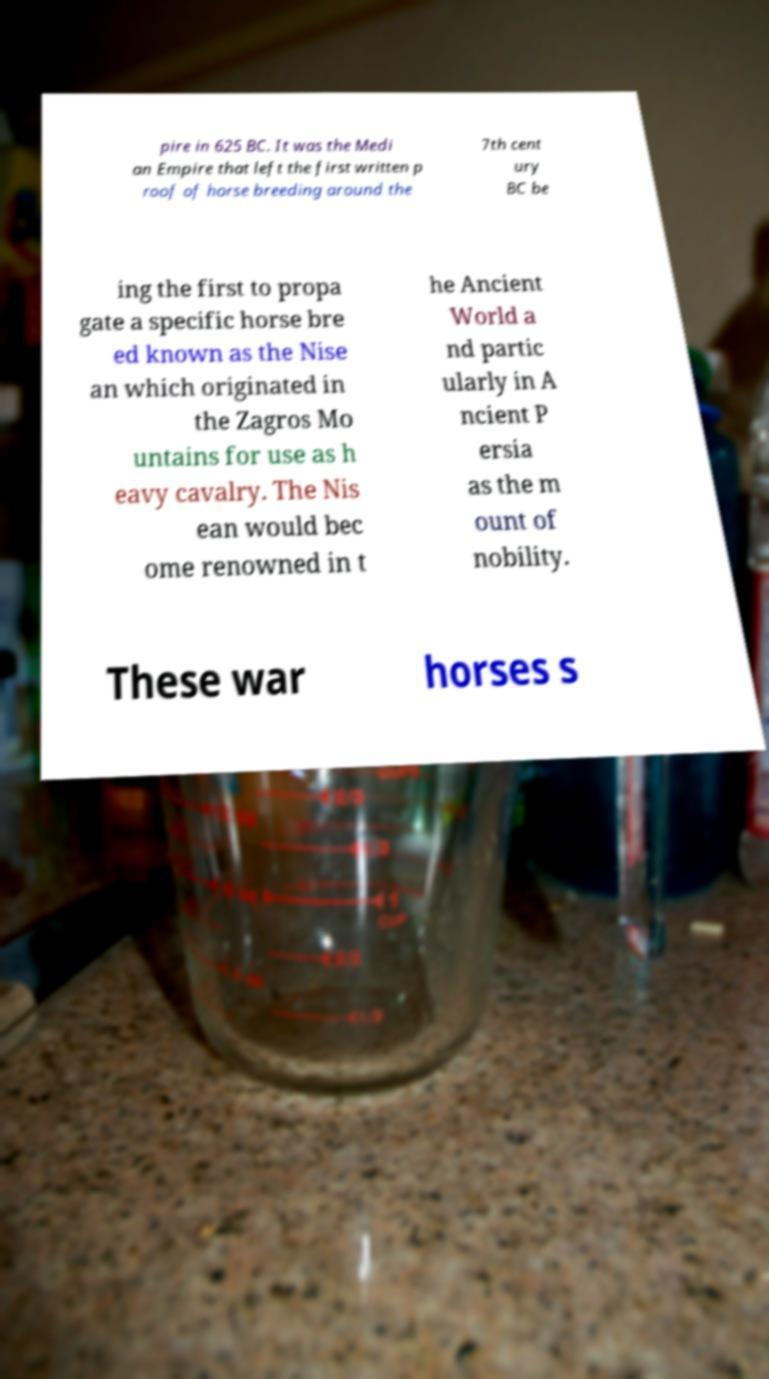Please identify and transcribe the text found in this image. pire in 625 BC. It was the Medi an Empire that left the first written p roof of horse breeding around the 7th cent ury BC be ing the first to propa gate a specific horse bre ed known as the Nise an which originated in the Zagros Mo untains for use as h eavy cavalry. The Nis ean would bec ome renowned in t he Ancient World a nd partic ularly in A ncient P ersia as the m ount of nobility. These war horses s 